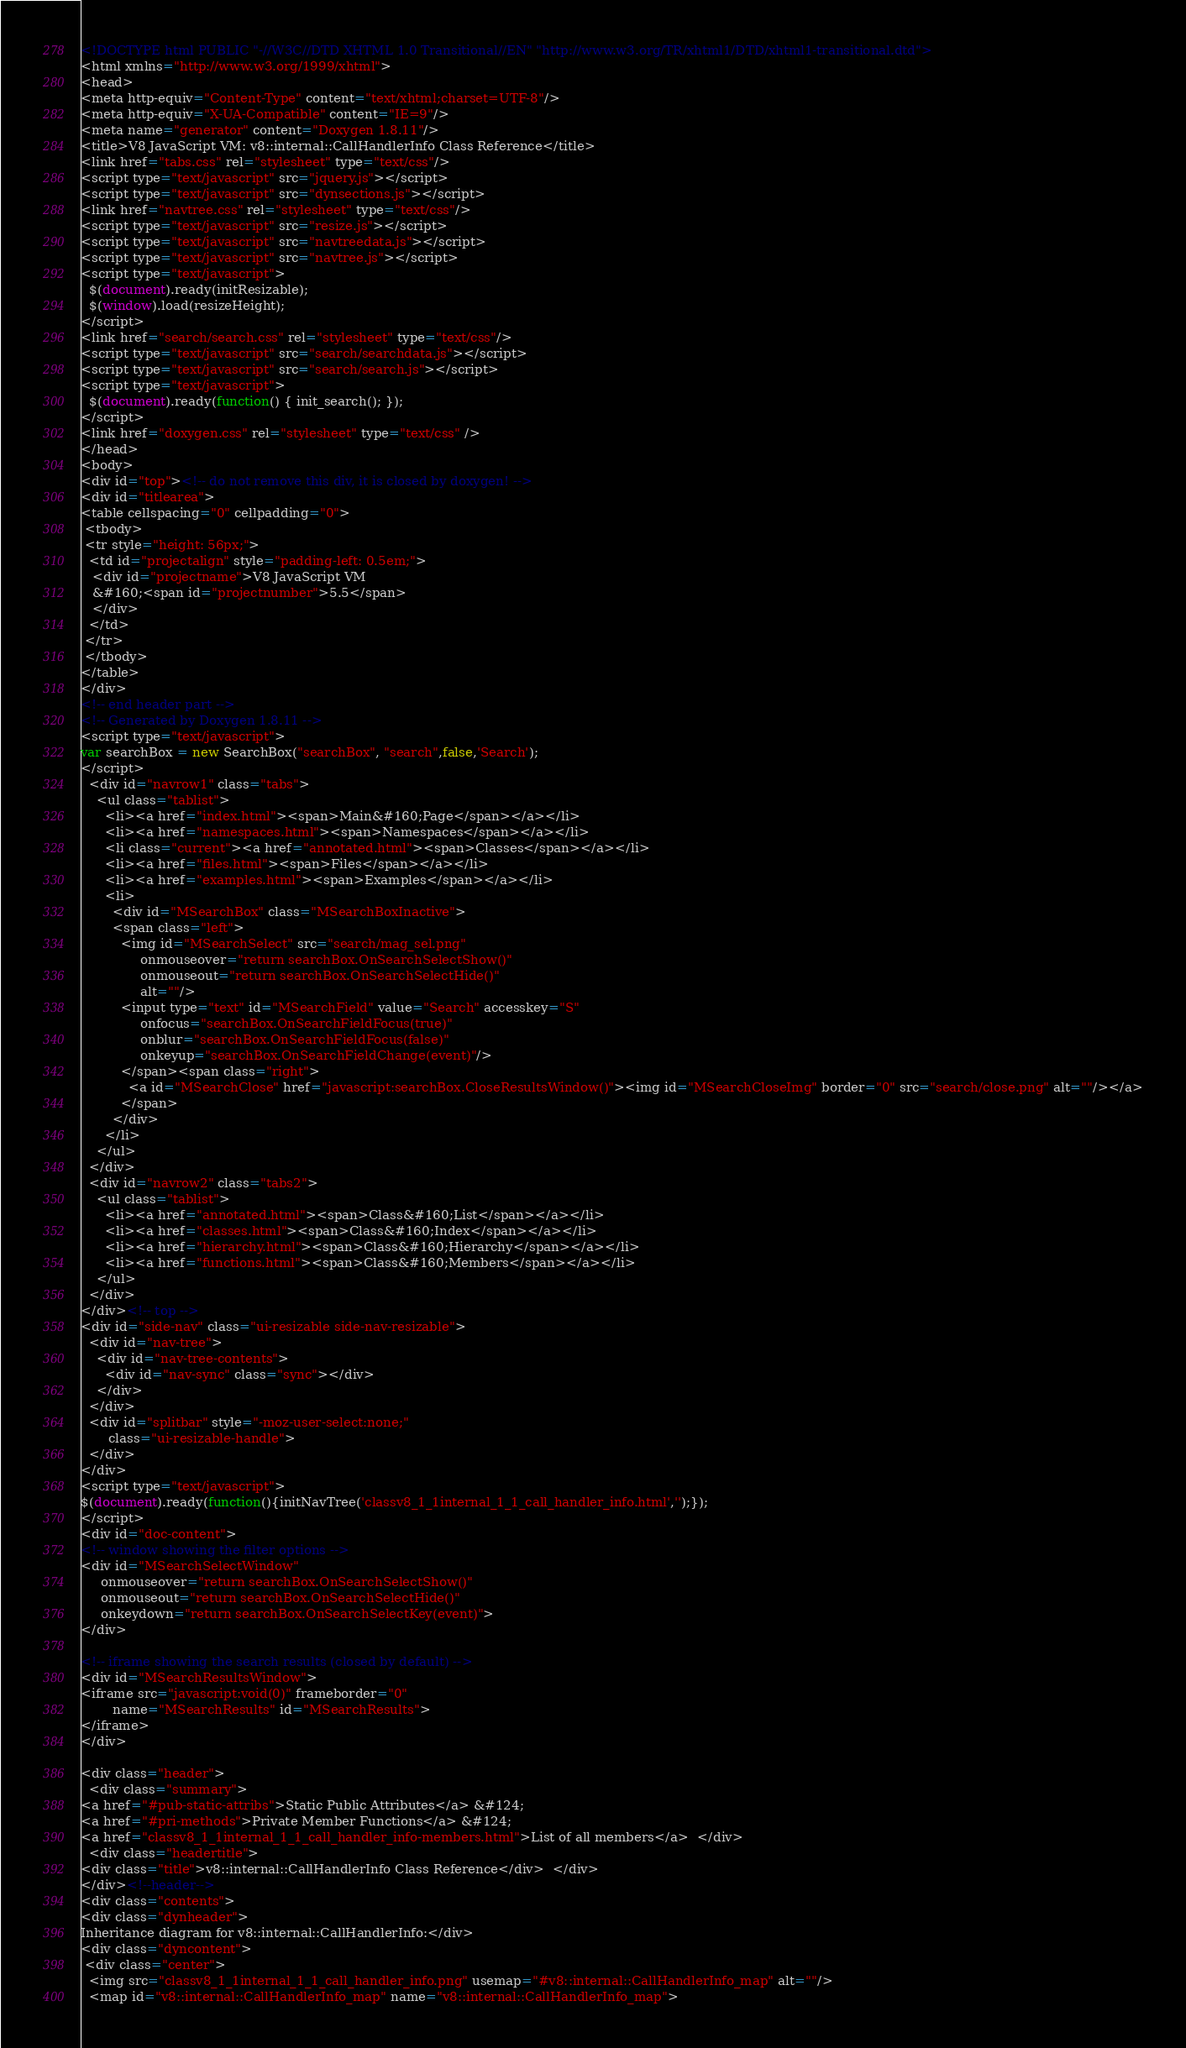<code> <loc_0><loc_0><loc_500><loc_500><_HTML_><!DOCTYPE html PUBLIC "-//W3C//DTD XHTML 1.0 Transitional//EN" "http://www.w3.org/TR/xhtml1/DTD/xhtml1-transitional.dtd">
<html xmlns="http://www.w3.org/1999/xhtml">
<head>
<meta http-equiv="Content-Type" content="text/xhtml;charset=UTF-8"/>
<meta http-equiv="X-UA-Compatible" content="IE=9"/>
<meta name="generator" content="Doxygen 1.8.11"/>
<title>V8 JavaScript VM: v8::internal::CallHandlerInfo Class Reference</title>
<link href="tabs.css" rel="stylesheet" type="text/css"/>
<script type="text/javascript" src="jquery.js"></script>
<script type="text/javascript" src="dynsections.js"></script>
<link href="navtree.css" rel="stylesheet" type="text/css"/>
<script type="text/javascript" src="resize.js"></script>
<script type="text/javascript" src="navtreedata.js"></script>
<script type="text/javascript" src="navtree.js"></script>
<script type="text/javascript">
  $(document).ready(initResizable);
  $(window).load(resizeHeight);
</script>
<link href="search/search.css" rel="stylesheet" type="text/css"/>
<script type="text/javascript" src="search/searchdata.js"></script>
<script type="text/javascript" src="search/search.js"></script>
<script type="text/javascript">
  $(document).ready(function() { init_search(); });
</script>
<link href="doxygen.css" rel="stylesheet" type="text/css" />
</head>
<body>
<div id="top"><!-- do not remove this div, it is closed by doxygen! -->
<div id="titlearea">
<table cellspacing="0" cellpadding="0">
 <tbody>
 <tr style="height: 56px;">
  <td id="projectalign" style="padding-left: 0.5em;">
   <div id="projectname">V8 JavaScript VM
   &#160;<span id="projectnumber">5.5</span>
   </div>
  </td>
 </tr>
 </tbody>
</table>
</div>
<!-- end header part -->
<!-- Generated by Doxygen 1.8.11 -->
<script type="text/javascript">
var searchBox = new SearchBox("searchBox", "search",false,'Search');
</script>
  <div id="navrow1" class="tabs">
    <ul class="tablist">
      <li><a href="index.html"><span>Main&#160;Page</span></a></li>
      <li><a href="namespaces.html"><span>Namespaces</span></a></li>
      <li class="current"><a href="annotated.html"><span>Classes</span></a></li>
      <li><a href="files.html"><span>Files</span></a></li>
      <li><a href="examples.html"><span>Examples</span></a></li>
      <li>
        <div id="MSearchBox" class="MSearchBoxInactive">
        <span class="left">
          <img id="MSearchSelect" src="search/mag_sel.png"
               onmouseover="return searchBox.OnSearchSelectShow()"
               onmouseout="return searchBox.OnSearchSelectHide()"
               alt=""/>
          <input type="text" id="MSearchField" value="Search" accesskey="S"
               onfocus="searchBox.OnSearchFieldFocus(true)" 
               onblur="searchBox.OnSearchFieldFocus(false)" 
               onkeyup="searchBox.OnSearchFieldChange(event)"/>
          </span><span class="right">
            <a id="MSearchClose" href="javascript:searchBox.CloseResultsWindow()"><img id="MSearchCloseImg" border="0" src="search/close.png" alt=""/></a>
          </span>
        </div>
      </li>
    </ul>
  </div>
  <div id="navrow2" class="tabs2">
    <ul class="tablist">
      <li><a href="annotated.html"><span>Class&#160;List</span></a></li>
      <li><a href="classes.html"><span>Class&#160;Index</span></a></li>
      <li><a href="hierarchy.html"><span>Class&#160;Hierarchy</span></a></li>
      <li><a href="functions.html"><span>Class&#160;Members</span></a></li>
    </ul>
  </div>
</div><!-- top -->
<div id="side-nav" class="ui-resizable side-nav-resizable">
  <div id="nav-tree">
    <div id="nav-tree-contents">
      <div id="nav-sync" class="sync"></div>
    </div>
  </div>
  <div id="splitbar" style="-moz-user-select:none;" 
       class="ui-resizable-handle">
  </div>
</div>
<script type="text/javascript">
$(document).ready(function(){initNavTree('classv8_1_1internal_1_1_call_handler_info.html','');});
</script>
<div id="doc-content">
<!-- window showing the filter options -->
<div id="MSearchSelectWindow"
     onmouseover="return searchBox.OnSearchSelectShow()"
     onmouseout="return searchBox.OnSearchSelectHide()"
     onkeydown="return searchBox.OnSearchSelectKey(event)">
</div>

<!-- iframe showing the search results (closed by default) -->
<div id="MSearchResultsWindow">
<iframe src="javascript:void(0)" frameborder="0" 
        name="MSearchResults" id="MSearchResults">
</iframe>
</div>

<div class="header">
  <div class="summary">
<a href="#pub-static-attribs">Static Public Attributes</a> &#124;
<a href="#pri-methods">Private Member Functions</a> &#124;
<a href="classv8_1_1internal_1_1_call_handler_info-members.html">List of all members</a>  </div>
  <div class="headertitle">
<div class="title">v8::internal::CallHandlerInfo Class Reference</div>  </div>
</div><!--header-->
<div class="contents">
<div class="dynheader">
Inheritance diagram for v8::internal::CallHandlerInfo:</div>
<div class="dyncontent">
 <div class="center">
  <img src="classv8_1_1internal_1_1_call_handler_info.png" usemap="#v8::internal::CallHandlerInfo_map" alt=""/>
  <map id="v8::internal::CallHandlerInfo_map" name="v8::internal::CallHandlerInfo_map"></code> 